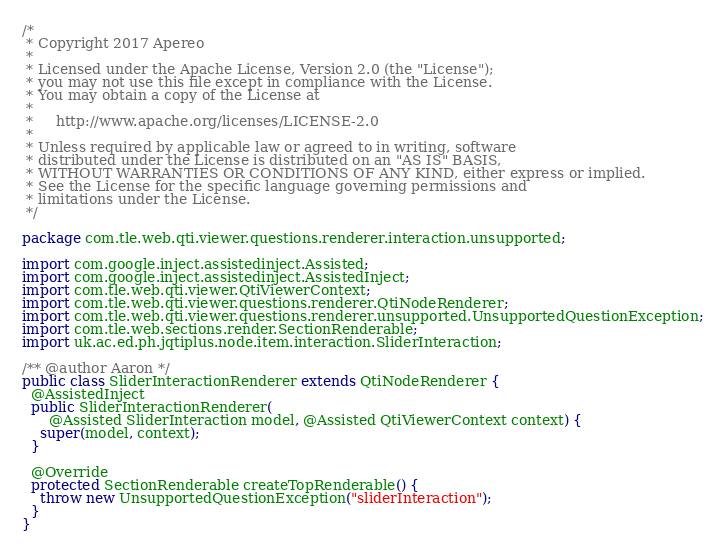Convert code to text. <code><loc_0><loc_0><loc_500><loc_500><_Java_>/*
 * Copyright 2017 Apereo
 *
 * Licensed under the Apache License, Version 2.0 (the "License");
 * you may not use this file except in compliance with the License.
 * You may obtain a copy of the License at
 *
 *     http://www.apache.org/licenses/LICENSE-2.0
 *
 * Unless required by applicable law or agreed to in writing, software
 * distributed under the License is distributed on an "AS IS" BASIS,
 * WITHOUT WARRANTIES OR CONDITIONS OF ANY KIND, either express or implied.
 * See the License for the specific language governing permissions and
 * limitations under the License.
 */

package com.tle.web.qti.viewer.questions.renderer.interaction.unsupported;

import com.google.inject.assistedinject.Assisted;
import com.google.inject.assistedinject.AssistedInject;
import com.tle.web.qti.viewer.QtiViewerContext;
import com.tle.web.qti.viewer.questions.renderer.QtiNodeRenderer;
import com.tle.web.qti.viewer.questions.renderer.unsupported.UnsupportedQuestionException;
import com.tle.web.sections.render.SectionRenderable;
import uk.ac.ed.ph.jqtiplus.node.item.interaction.SliderInteraction;

/** @author Aaron */
public class SliderInteractionRenderer extends QtiNodeRenderer {
  @AssistedInject
  public SliderInteractionRenderer(
      @Assisted SliderInteraction model, @Assisted QtiViewerContext context) {
    super(model, context);
  }

  @Override
  protected SectionRenderable createTopRenderable() {
    throw new UnsupportedQuestionException("sliderInteraction");
  }
}
</code> 